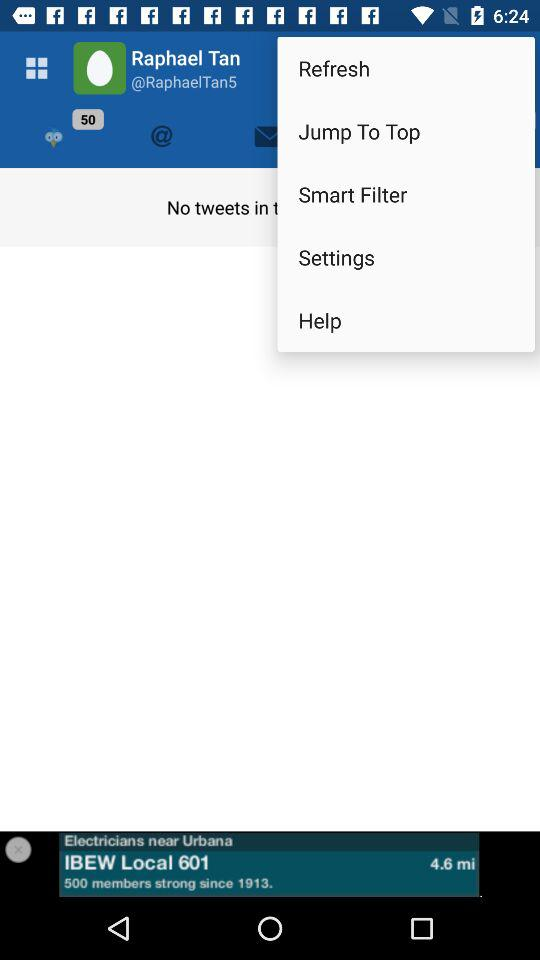What is the distance to the electrician?
Answer the question using a single word or phrase. 4.6 mi 